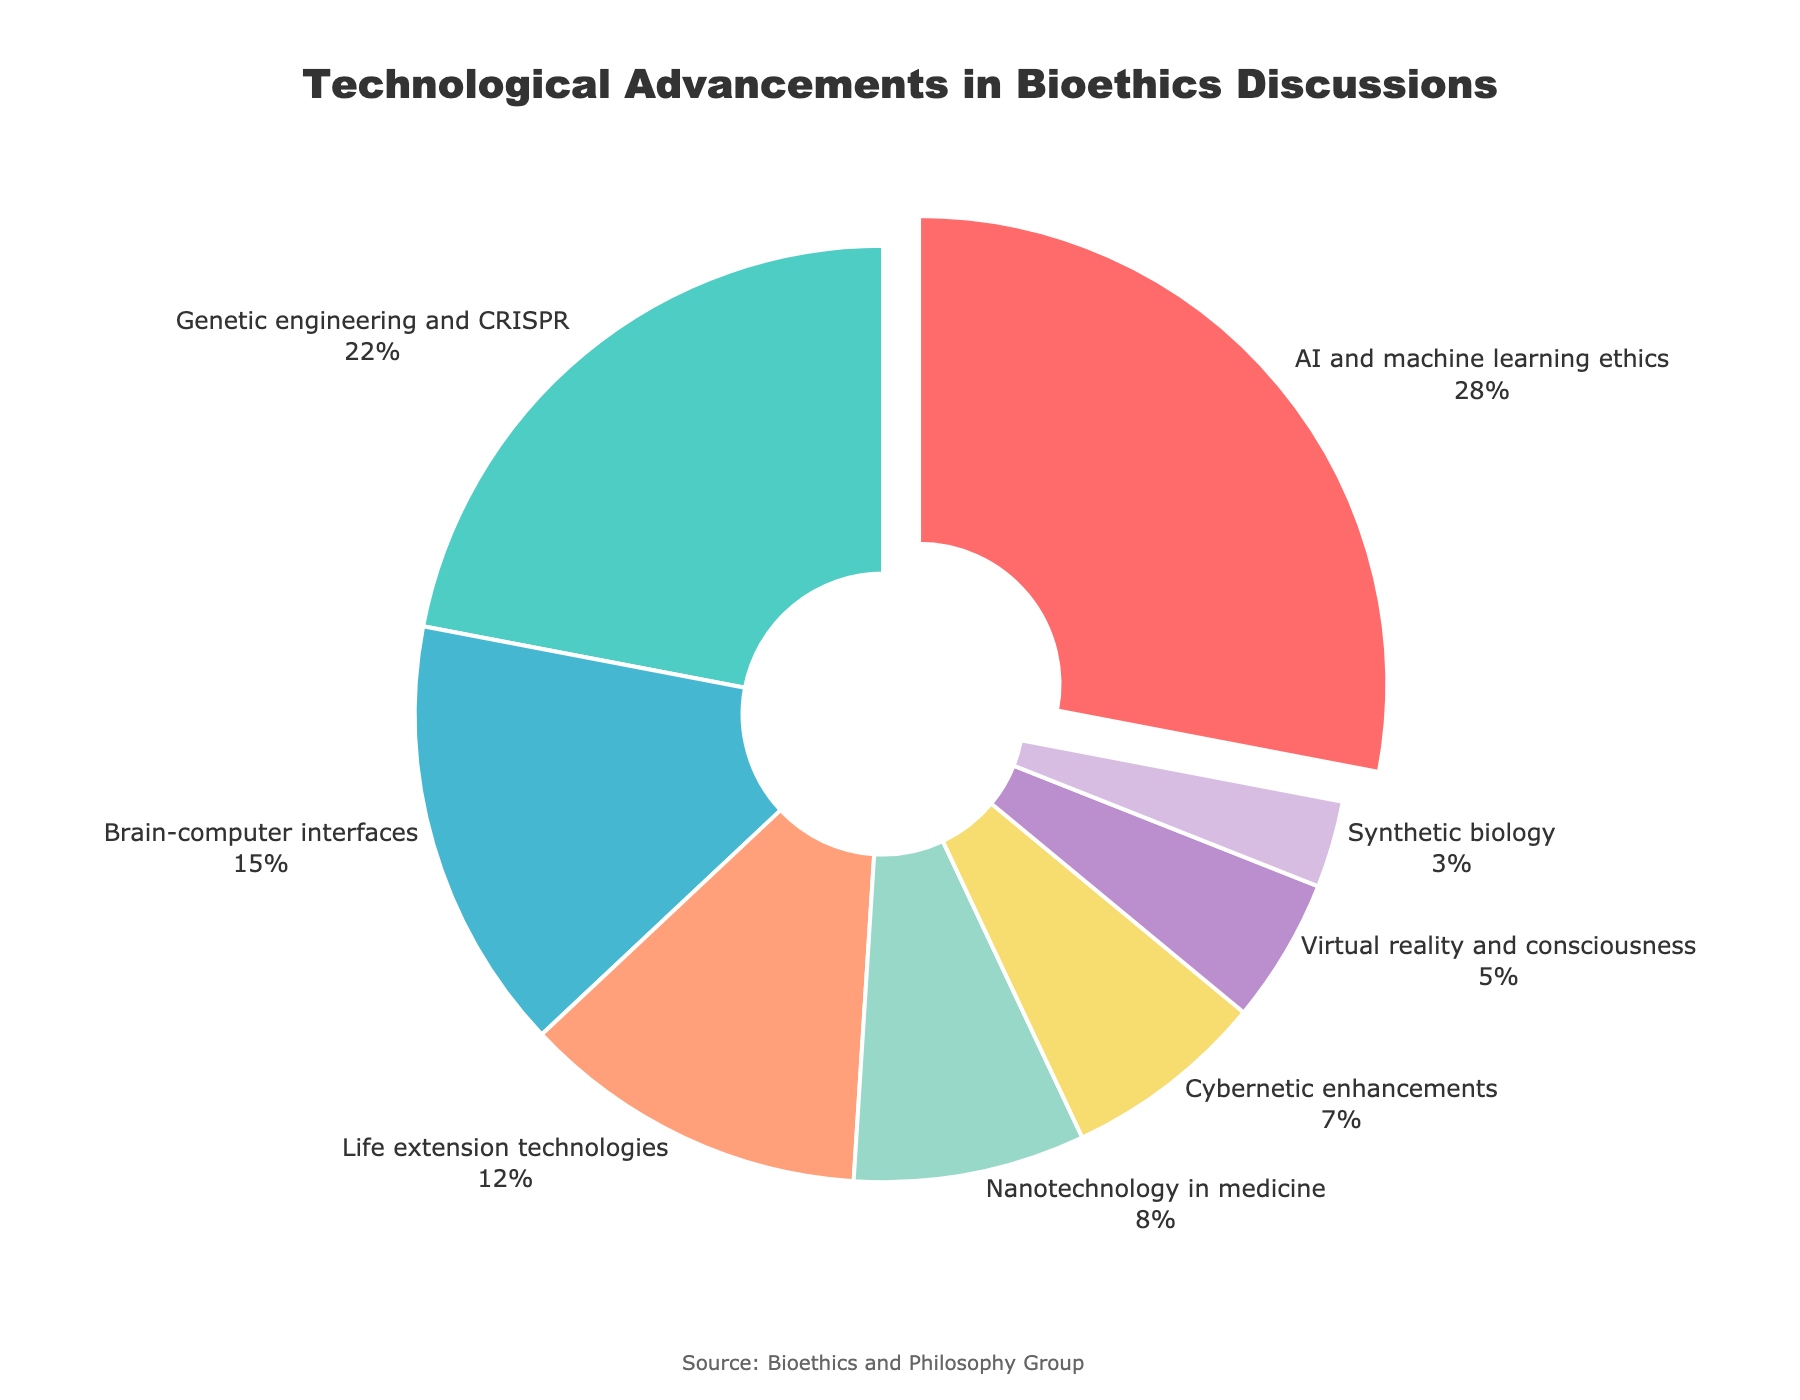Which category occupies the largest segment of the pie chart? The largest segment corresponds to the category with the highest percentage value. In the chart, "AI and machine learning ethics" occupies 28%, which is the largest percentage among all categories.
Answer: AI and machine learning ethics What is the combined percentage of Genetic engineering and CRISPR, and Brain-computer interfaces? To find the combined percentage, sum the percentages of "Genetic engineering and CRISPR" (22%) and "Brain-computer interfaces" (15%): 22 + 15 = 37%.
Answer: 37% Which technology has the smallest presence in the discussions? The smallest presence is indicated by the smallest segment in the pie chart. "Synthetic biology" has the smallest percentage of 3%.
Answer: Synthetic biology How much larger is the percentage of AI and machine learning ethics compared to Cybernetic enhancements? The percentage of "AI and machine learning ethics" is 28%, and "Cybernetic enhancements" is 7%. The difference is 28 - 7 = 21%.
Answer: 21% Arrange the categories in descending order of their percentage share. To arrange the categories, list them based on descending percentage values: "AI and machine learning ethics" (28%), "Genetic engineering and CRISPR" (22%), "Brain-computer interfaces" (15%), "Life extension technologies" (12%), "Nanotechnology in medicine" (8%), "Cybernetic enhancements" (7%), "Virtual reality and consciousness" (5%), "Synthetic biology" (3%).
Answer: AI and machine learning ethics, Genetic engineering and CRISPR, Brain-computer interfaces, Life extension technologies, Nanotechnology in medicine, Cybernetic enhancements, Virtual reality and consciousness, Synthetic biology What percentage of discussions do Virtual reality and consciousness, and Synthetic biology contribute together? Add the percentages of "Virtual reality and consciousness" (5%) and "Synthetic biology" (3%): 5 + 3 = 8%.
Answer: 8% Which two categories have the closest percentage values, and what is their difference? "Nanotechnology in medicine" (8%) and "Cybernetic enhancements" (7%) have the closest values. The difference is 8 - 7 = 1%.
Answer: Nanotechnology in medicine and Cybernetic enhancements, 1% Identify the segment that is highlighted (pulled out) in the pie chart and its percentage. The highlighted segment corresponds to the category that is visually pulled out in the pie chart. In this case, "AI and machine learning ethics" is pulled out, and its percentage is 28%.
Answer: AI and machine learning ethics, 28% What is the total percentage of discussions involving all categories except the top two? The top two categories are "AI and machine learning ethics" (28%) and "Genetic engineering and CRISPR" (22%). The total percentage without them is 100% - 28% - 22% = 50%.
Answer: 50% 